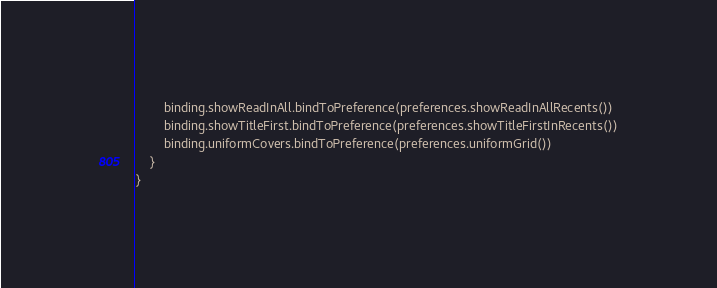<code> <loc_0><loc_0><loc_500><loc_500><_Kotlin_>        binding.showReadInAll.bindToPreference(preferences.showReadInAllRecents())
        binding.showTitleFirst.bindToPreference(preferences.showTitleFirstInRecents())
        binding.uniformCovers.bindToPreference(preferences.uniformGrid())
    }
}
</code> 